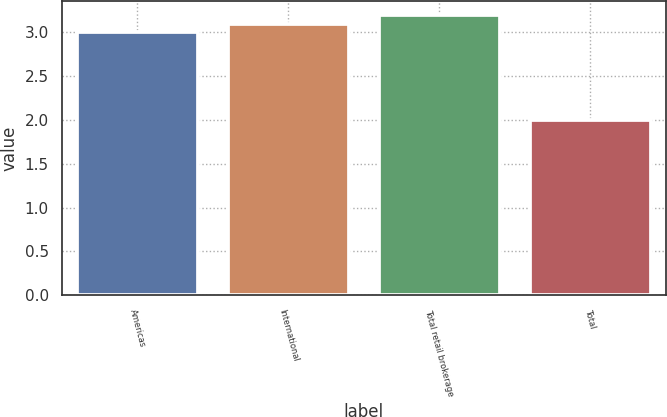<chart> <loc_0><loc_0><loc_500><loc_500><bar_chart><fcel>Americas<fcel>International<fcel>Total retail brokerage<fcel>Total<nl><fcel>3<fcel>3.1<fcel>3.2<fcel>2<nl></chart> 